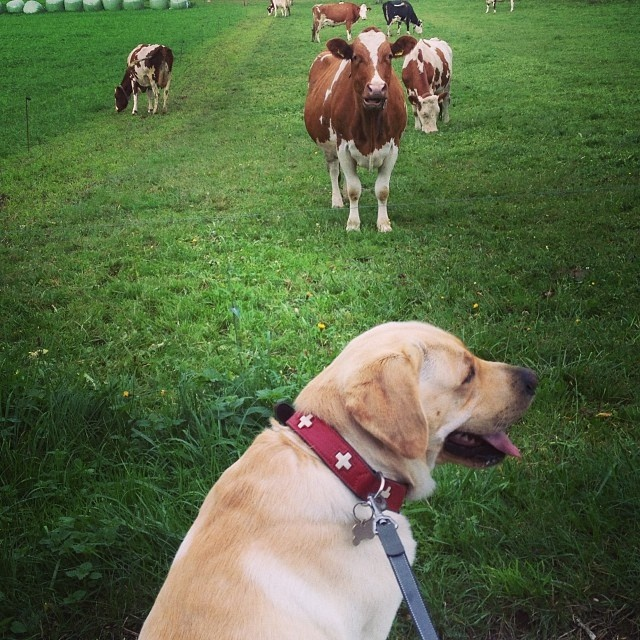Describe the objects in this image and their specific colors. I can see dog in green, tan, and lightgray tones, cow in green, maroon, brown, black, and darkgray tones, cow in green, lightgray, gray, maroon, and darkgray tones, cow in green, black, gray, darkgreen, and maroon tones, and cow in green, brown, and tan tones in this image. 